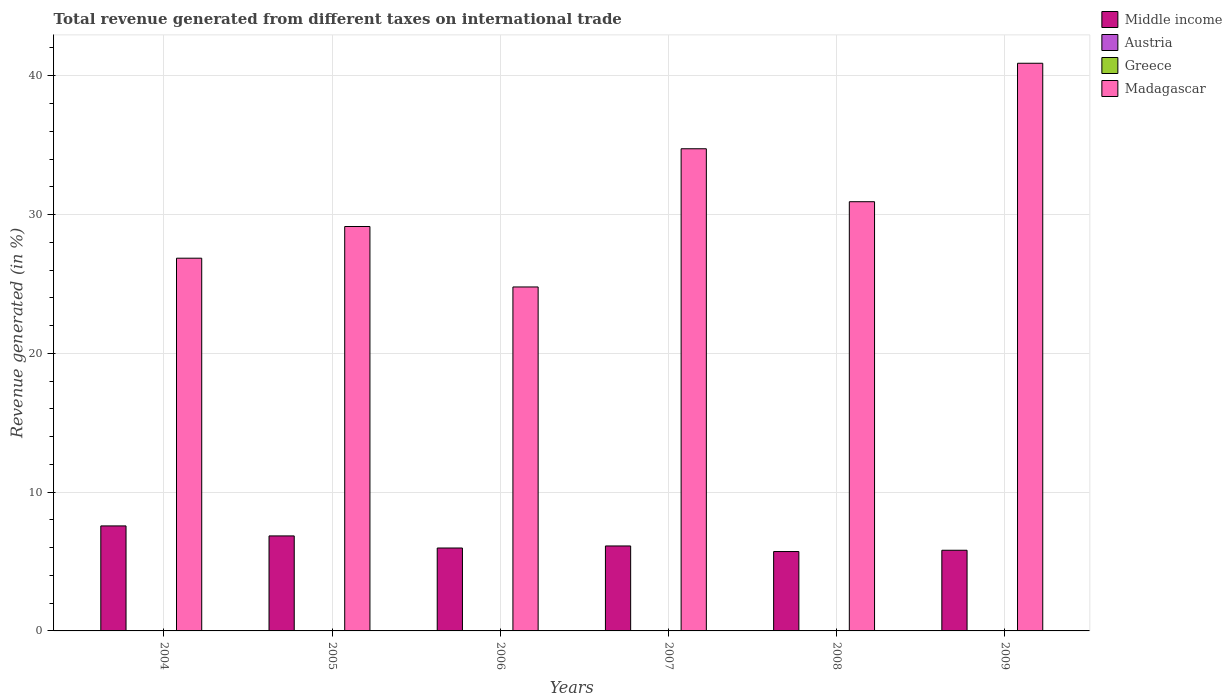How many different coloured bars are there?
Ensure brevity in your answer.  4. Are the number of bars per tick equal to the number of legend labels?
Keep it short and to the point. No. How many bars are there on the 3rd tick from the left?
Your answer should be compact. 4. In how many cases, is the number of bars for a given year not equal to the number of legend labels?
Keep it short and to the point. 2. What is the total revenue generated in Middle income in 2005?
Your response must be concise. 6.84. Across all years, what is the maximum total revenue generated in Middle income?
Keep it short and to the point. 7.57. Across all years, what is the minimum total revenue generated in Greece?
Offer a terse response. 0. What is the total total revenue generated in Middle income in the graph?
Give a very brief answer. 38.04. What is the difference between the total revenue generated in Greece in 2005 and that in 2008?
Your answer should be compact. 0. What is the difference between the total revenue generated in Greece in 2007 and the total revenue generated in Middle income in 2006?
Provide a short and direct response. -5.97. What is the average total revenue generated in Madagascar per year?
Offer a terse response. 31.22. In the year 2007, what is the difference between the total revenue generated in Greece and total revenue generated in Middle income?
Your answer should be very brief. -6.11. In how many years, is the total revenue generated in Madagascar greater than 16 %?
Provide a short and direct response. 6. What is the ratio of the total revenue generated in Greece in 2007 to that in 2008?
Offer a terse response. 3.65. Is the total revenue generated in Greece in 2004 less than that in 2005?
Offer a terse response. No. Is the difference between the total revenue generated in Greece in 2005 and 2009 greater than the difference between the total revenue generated in Middle income in 2005 and 2009?
Make the answer very short. No. What is the difference between the highest and the second highest total revenue generated in Greece?
Make the answer very short. 0.01. What is the difference between the highest and the lowest total revenue generated in Madagascar?
Keep it short and to the point. 16.12. In how many years, is the total revenue generated in Austria greater than the average total revenue generated in Austria taken over all years?
Keep it short and to the point. 2. Is it the case that in every year, the sum of the total revenue generated in Madagascar and total revenue generated in Austria is greater than the sum of total revenue generated in Middle income and total revenue generated in Greece?
Offer a terse response. Yes. Are all the bars in the graph horizontal?
Your response must be concise. No. What is the difference between two consecutive major ticks on the Y-axis?
Your response must be concise. 10. Does the graph contain any zero values?
Make the answer very short. Yes. Does the graph contain grids?
Offer a terse response. Yes. How many legend labels are there?
Make the answer very short. 4. How are the legend labels stacked?
Ensure brevity in your answer.  Vertical. What is the title of the graph?
Give a very brief answer. Total revenue generated from different taxes on international trade. What is the label or title of the X-axis?
Keep it short and to the point. Years. What is the label or title of the Y-axis?
Make the answer very short. Revenue generated (in %). What is the Revenue generated (in %) in Middle income in 2004?
Your answer should be compact. 7.57. What is the Revenue generated (in %) in Austria in 2004?
Provide a short and direct response. 0. What is the Revenue generated (in %) in Greece in 2004?
Provide a short and direct response. 0.01. What is the Revenue generated (in %) in Madagascar in 2004?
Make the answer very short. 26.85. What is the Revenue generated (in %) in Middle income in 2005?
Make the answer very short. 6.84. What is the Revenue generated (in %) of Austria in 2005?
Offer a terse response. 0. What is the Revenue generated (in %) in Greece in 2005?
Make the answer very short. 0. What is the Revenue generated (in %) in Madagascar in 2005?
Keep it short and to the point. 29.14. What is the Revenue generated (in %) of Middle income in 2006?
Keep it short and to the point. 5.97. What is the Revenue generated (in %) in Austria in 2006?
Provide a short and direct response. 7.23475776067297e-5. What is the Revenue generated (in %) in Greece in 2006?
Your answer should be very brief. 0.01. What is the Revenue generated (in %) in Madagascar in 2006?
Ensure brevity in your answer.  24.78. What is the Revenue generated (in %) in Middle income in 2007?
Your answer should be very brief. 6.12. What is the Revenue generated (in %) of Austria in 2007?
Offer a terse response. 0. What is the Revenue generated (in %) in Greece in 2007?
Keep it short and to the point. 0.01. What is the Revenue generated (in %) of Madagascar in 2007?
Provide a short and direct response. 34.74. What is the Revenue generated (in %) in Middle income in 2008?
Your response must be concise. 5.72. What is the Revenue generated (in %) in Greece in 2008?
Offer a very short reply. 0. What is the Revenue generated (in %) of Madagascar in 2008?
Offer a terse response. 30.92. What is the Revenue generated (in %) of Middle income in 2009?
Your response must be concise. 5.81. What is the Revenue generated (in %) of Austria in 2009?
Offer a very short reply. 6.92844166875675e-5. What is the Revenue generated (in %) in Greece in 2009?
Your answer should be very brief. 0. What is the Revenue generated (in %) in Madagascar in 2009?
Offer a terse response. 40.9. Across all years, what is the maximum Revenue generated (in %) in Middle income?
Offer a very short reply. 7.57. Across all years, what is the maximum Revenue generated (in %) of Austria?
Your answer should be compact. 0. Across all years, what is the maximum Revenue generated (in %) in Greece?
Ensure brevity in your answer.  0.01. Across all years, what is the maximum Revenue generated (in %) in Madagascar?
Make the answer very short. 40.9. Across all years, what is the minimum Revenue generated (in %) of Middle income?
Offer a terse response. 5.72. Across all years, what is the minimum Revenue generated (in %) in Greece?
Offer a very short reply. 0. Across all years, what is the minimum Revenue generated (in %) in Madagascar?
Provide a short and direct response. 24.78. What is the total Revenue generated (in %) in Middle income in the graph?
Ensure brevity in your answer.  38.04. What is the total Revenue generated (in %) in Austria in the graph?
Your response must be concise. 0.01. What is the total Revenue generated (in %) in Greece in the graph?
Give a very brief answer. 0.03. What is the total Revenue generated (in %) of Madagascar in the graph?
Offer a very short reply. 187.34. What is the difference between the Revenue generated (in %) in Middle income in 2004 and that in 2005?
Give a very brief answer. 0.72. What is the difference between the Revenue generated (in %) of Austria in 2004 and that in 2005?
Provide a succinct answer. 0. What is the difference between the Revenue generated (in %) of Greece in 2004 and that in 2005?
Your response must be concise. 0.01. What is the difference between the Revenue generated (in %) of Madagascar in 2004 and that in 2005?
Offer a very short reply. -2.28. What is the difference between the Revenue generated (in %) in Middle income in 2004 and that in 2006?
Keep it short and to the point. 1.59. What is the difference between the Revenue generated (in %) of Austria in 2004 and that in 2006?
Your answer should be compact. 0. What is the difference between the Revenue generated (in %) of Greece in 2004 and that in 2006?
Ensure brevity in your answer.  0.01. What is the difference between the Revenue generated (in %) of Madagascar in 2004 and that in 2006?
Give a very brief answer. 2.07. What is the difference between the Revenue generated (in %) of Middle income in 2004 and that in 2007?
Keep it short and to the point. 1.44. What is the difference between the Revenue generated (in %) of Greece in 2004 and that in 2007?
Give a very brief answer. 0.01. What is the difference between the Revenue generated (in %) in Madagascar in 2004 and that in 2007?
Offer a terse response. -7.88. What is the difference between the Revenue generated (in %) in Middle income in 2004 and that in 2008?
Your answer should be very brief. 1.85. What is the difference between the Revenue generated (in %) in Greece in 2004 and that in 2008?
Your answer should be compact. 0.01. What is the difference between the Revenue generated (in %) of Madagascar in 2004 and that in 2008?
Provide a short and direct response. -4.07. What is the difference between the Revenue generated (in %) in Middle income in 2004 and that in 2009?
Your answer should be very brief. 1.75. What is the difference between the Revenue generated (in %) of Austria in 2004 and that in 2009?
Make the answer very short. 0. What is the difference between the Revenue generated (in %) of Greece in 2004 and that in 2009?
Your answer should be very brief. 0.01. What is the difference between the Revenue generated (in %) of Madagascar in 2004 and that in 2009?
Your response must be concise. -14.05. What is the difference between the Revenue generated (in %) in Middle income in 2005 and that in 2006?
Keep it short and to the point. 0.87. What is the difference between the Revenue generated (in %) of Austria in 2005 and that in 2006?
Offer a terse response. 0. What is the difference between the Revenue generated (in %) of Greece in 2005 and that in 2006?
Your answer should be very brief. -0. What is the difference between the Revenue generated (in %) in Madagascar in 2005 and that in 2006?
Offer a terse response. 4.36. What is the difference between the Revenue generated (in %) of Middle income in 2005 and that in 2007?
Give a very brief answer. 0.72. What is the difference between the Revenue generated (in %) in Greece in 2005 and that in 2007?
Your answer should be very brief. -0. What is the difference between the Revenue generated (in %) in Madagascar in 2005 and that in 2007?
Provide a succinct answer. -5.6. What is the difference between the Revenue generated (in %) in Middle income in 2005 and that in 2008?
Provide a succinct answer. 1.13. What is the difference between the Revenue generated (in %) of Greece in 2005 and that in 2008?
Your response must be concise. 0. What is the difference between the Revenue generated (in %) in Madagascar in 2005 and that in 2008?
Make the answer very short. -1.79. What is the difference between the Revenue generated (in %) of Middle income in 2005 and that in 2009?
Offer a terse response. 1.03. What is the difference between the Revenue generated (in %) of Austria in 2005 and that in 2009?
Offer a terse response. 0. What is the difference between the Revenue generated (in %) of Greece in 2005 and that in 2009?
Provide a short and direct response. 0. What is the difference between the Revenue generated (in %) in Madagascar in 2005 and that in 2009?
Your answer should be very brief. -11.76. What is the difference between the Revenue generated (in %) in Middle income in 2006 and that in 2007?
Your response must be concise. -0.15. What is the difference between the Revenue generated (in %) of Greece in 2006 and that in 2007?
Provide a succinct answer. -0. What is the difference between the Revenue generated (in %) in Madagascar in 2006 and that in 2007?
Give a very brief answer. -9.96. What is the difference between the Revenue generated (in %) of Middle income in 2006 and that in 2008?
Keep it short and to the point. 0.25. What is the difference between the Revenue generated (in %) in Greece in 2006 and that in 2008?
Give a very brief answer. 0. What is the difference between the Revenue generated (in %) in Madagascar in 2006 and that in 2008?
Your answer should be very brief. -6.14. What is the difference between the Revenue generated (in %) in Middle income in 2006 and that in 2009?
Keep it short and to the point. 0.16. What is the difference between the Revenue generated (in %) in Austria in 2006 and that in 2009?
Keep it short and to the point. 0. What is the difference between the Revenue generated (in %) of Greece in 2006 and that in 2009?
Provide a short and direct response. 0. What is the difference between the Revenue generated (in %) of Madagascar in 2006 and that in 2009?
Make the answer very short. -16.12. What is the difference between the Revenue generated (in %) of Middle income in 2007 and that in 2008?
Make the answer very short. 0.4. What is the difference between the Revenue generated (in %) of Greece in 2007 and that in 2008?
Provide a succinct answer. 0.01. What is the difference between the Revenue generated (in %) in Madagascar in 2007 and that in 2008?
Offer a very short reply. 3.82. What is the difference between the Revenue generated (in %) in Middle income in 2007 and that in 2009?
Keep it short and to the point. 0.31. What is the difference between the Revenue generated (in %) of Greece in 2007 and that in 2009?
Keep it short and to the point. 0.01. What is the difference between the Revenue generated (in %) of Madagascar in 2007 and that in 2009?
Give a very brief answer. -6.16. What is the difference between the Revenue generated (in %) of Middle income in 2008 and that in 2009?
Offer a terse response. -0.09. What is the difference between the Revenue generated (in %) of Greece in 2008 and that in 2009?
Provide a succinct answer. 0. What is the difference between the Revenue generated (in %) of Madagascar in 2008 and that in 2009?
Provide a short and direct response. -9.98. What is the difference between the Revenue generated (in %) in Middle income in 2004 and the Revenue generated (in %) in Austria in 2005?
Make the answer very short. 7.56. What is the difference between the Revenue generated (in %) of Middle income in 2004 and the Revenue generated (in %) of Greece in 2005?
Provide a short and direct response. 7.56. What is the difference between the Revenue generated (in %) in Middle income in 2004 and the Revenue generated (in %) in Madagascar in 2005?
Provide a succinct answer. -21.57. What is the difference between the Revenue generated (in %) of Austria in 2004 and the Revenue generated (in %) of Madagascar in 2005?
Your response must be concise. -29.13. What is the difference between the Revenue generated (in %) of Greece in 2004 and the Revenue generated (in %) of Madagascar in 2005?
Provide a succinct answer. -29.12. What is the difference between the Revenue generated (in %) in Middle income in 2004 and the Revenue generated (in %) in Austria in 2006?
Ensure brevity in your answer.  7.57. What is the difference between the Revenue generated (in %) of Middle income in 2004 and the Revenue generated (in %) of Greece in 2006?
Offer a terse response. 7.56. What is the difference between the Revenue generated (in %) of Middle income in 2004 and the Revenue generated (in %) of Madagascar in 2006?
Give a very brief answer. -17.22. What is the difference between the Revenue generated (in %) in Austria in 2004 and the Revenue generated (in %) in Greece in 2006?
Give a very brief answer. -0. What is the difference between the Revenue generated (in %) of Austria in 2004 and the Revenue generated (in %) of Madagascar in 2006?
Provide a short and direct response. -24.78. What is the difference between the Revenue generated (in %) in Greece in 2004 and the Revenue generated (in %) in Madagascar in 2006?
Provide a succinct answer. -24.77. What is the difference between the Revenue generated (in %) in Middle income in 2004 and the Revenue generated (in %) in Greece in 2007?
Make the answer very short. 7.56. What is the difference between the Revenue generated (in %) of Middle income in 2004 and the Revenue generated (in %) of Madagascar in 2007?
Your answer should be compact. -27.17. What is the difference between the Revenue generated (in %) in Austria in 2004 and the Revenue generated (in %) in Greece in 2007?
Offer a terse response. -0. What is the difference between the Revenue generated (in %) in Austria in 2004 and the Revenue generated (in %) in Madagascar in 2007?
Offer a very short reply. -34.73. What is the difference between the Revenue generated (in %) in Greece in 2004 and the Revenue generated (in %) in Madagascar in 2007?
Your answer should be compact. -34.72. What is the difference between the Revenue generated (in %) of Middle income in 2004 and the Revenue generated (in %) of Greece in 2008?
Provide a short and direct response. 7.56. What is the difference between the Revenue generated (in %) in Middle income in 2004 and the Revenue generated (in %) in Madagascar in 2008?
Your response must be concise. -23.36. What is the difference between the Revenue generated (in %) in Austria in 2004 and the Revenue generated (in %) in Greece in 2008?
Offer a very short reply. 0. What is the difference between the Revenue generated (in %) of Austria in 2004 and the Revenue generated (in %) of Madagascar in 2008?
Provide a succinct answer. -30.92. What is the difference between the Revenue generated (in %) of Greece in 2004 and the Revenue generated (in %) of Madagascar in 2008?
Provide a succinct answer. -30.91. What is the difference between the Revenue generated (in %) in Middle income in 2004 and the Revenue generated (in %) in Austria in 2009?
Offer a very short reply. 7.57. What is the difference between the Revenue generated (in %) of Middle income in 2004 and the Revenue generated (in %) of Greece in 2009?
Provide a short and direct response. 7.56. What is the difference between the Revenue generated (in %) of Middle income in 2004 and the Revenue generated (in %) of Madagascar in 2009?
Your answer should be compact. -33.33. What is the difference between the Revenue generated (in %) of Austria in 2004 and the Revenue generated (in %) of Greece in 2009?
Provide a succinct answer. 0. What is the difference between the Revenue generated (in %) of Austria in 2004 and the Revenue generated (in %) of Madagascar in 2009?
Offer a very short reply. -40.9. What is the difference between the Revenue generated (in %) of Greece in 2004 and the Revenue generated (in %) of Madagascar in 2009?
Offer a very short reply. -40.88. What is the difference between the Revenue generated (in %) of Middle income in 2005 and the Revenue generated (in %) of Austria in 2006?
Make the answer very short. 6.84. What is the difference between the Revenue generated (in %) in Middle income in 2005 and the Revenue generated (in %) in Greece in 2006?
Make the answer very short. 6.84. What is the difference between the Revenue generated (in %) of Middle income in 2005 and the Revenue generated (in %) of Madagascar in 2006?
Ensure brevity in your answer.  -17.94. What is the difference between the Revenue generated (in %) in Austria in 2005 and the Revenue generated (in %) in Greece in 2006?
Keep it short and to the point. -0. What is the difference between the Revenue generated (in %) of Austria in 2005 and the Revenue generated (in %) of Madagascar in 2006?
Provide a succinct answer. -24.78. What is the difference between the Revenue generated (in %) of Greece in 2005 and the Revenue generated (in %) of Madagascar in 2006?
Ensure brevity in your answer.  -24.78. What is the difference between the Revenue generated (in %) in Middle income in 2005 and the Revenue generated (in %) in Greece in 2007?
Your response must be concise. 6.84. What is the difference between the Revenue generated (in %) in Middle income in 2005 and the Revenue generated (in %) in Madagascar in 2007?
Your answer should be very brief. -27.89. What is the difference between the Revenue generated (in %) of Austria in 2005 and the Revenue generated (in %) of Greece in 2007?
Your answer should be very brief. -0.01. What is the difference between the Revenue generated (in %) in Austria in 2005 and the Revenue generated (in %) in Madagascar in 2007?
Your answer should be compact. -34.74. What is the difference between the Revenue generated (in %) of Greece in 2005 and the Revenue generated (in %) of Madagascar in 2007?
Offer a very short reply. -34.73. What is the difference between the Revenue generated (in %) in Middle income in 2005 and the Revenue generated (in %) in Greece in 2008?
Keep it short and to the point. 6.84. What is the difference between the Revenue generated (in %) of Middle income in 2005 and the Revenue generated (in %) of Madagascar in 2008?
Provide a succinct answer. -24.08. What is the difference between the Revenue generated (in %) in Austria in 2005 and the Revenue generated (in %) in Greece in 2008?
Give a very brief answer. -0. What is the difference between the Revenue generated (in %) of Austria in 2005 and the Revenue generated (in %) of Madagascar in 2008?
Your answer should be compact. -30.92. What is the difference between the Revenue generated (in %) of Greece in 2005 and the Revenue generated (in %) of Madagascar in 2008?
Offer a very short reply. -30.92. What is the difference between the Revenue generated (in %) in Middle income in 2005 and the Revenue generated (in %) in Austria in 2009?
Your answer should be very brief. 6.84. What is the difference between the Revenue generated (in %) of Middle income in 2005 and the Revenue generated (in %) of Greece in 2009?
Provide a succinct answer. 6.84. What is the difference between the Revenue generated (in %) of Middle income in 2005 and the Revenue generated (in %) of Madagascar in 2009?
Provide a succinct answer. -34.05. What is the difference between the Revenue generated (in %) of Austria in 2005 and the Revenue generated (in %) of Greece in 2009?
Provide a succinct answer. 0. What is the difference between the Revenue generated (in %) of Austria in 2005 and the Revenue generated (in %) of Madagascar in 2009?
Your answer should be compact. -40.9. What is the difference between the Revenue generated (in %) of Greece in 2005 and the Revenue generated (in %) of Madagascar in 2009?
Your response must be concise. -40.9. What is the difference between the Revenue generated (in %) of Middle income in 2006 and the Revenue generated (in %) of Greece in 2007?
Provide a short and direct response. 5.97. What is the difference between the Revenue generated (in %) in Middle income in 2006 and the Revenue generated (in %) in Madagascar in 2007?
Provide a succinct answer. -28.77. What is the difference between the Revenue generated (in %) of Austria in 2006 and the Revenue generated (in %) of Greece in 2007?
Ensure brevity in your answer.  -0.01. What is the difference between the Revenue generated (in %) of Austria in 2006 and the Revenue generated (in %) of Madagascar in 2007?
Your answer should be very brief. -34.74. What is the difference between the Revenue generated (in %) in Greece in 2006 and the Revenue generated (in %) in Madagascar in 2007?
Your answer should be very brief. -34.73. What is the difference between the Revenue generated (in %) in Middle income in 2006 and the Revenue generated (in %) in Greece in 2008?
Keep it short and to the point. 5.97. What is the difference between the Revenue generated (in %) of Middle income in 2006 and the Revenue generated (in %) of Madagascar in 2008?
Give a very brief answer. -24.95. What is the difference between the Revenue generated (in %) in Austria in 2006 and the Revenue generated (in %) in Greece in 2008?
Make the answer very short. -0. What is the difference between the Revenue generated (in %) of Austria in 2006 and the Revenue generated (in %) of Madagascar in 2008?
Keep it short and to the point. -30.92. What is the difference between the Revenue generated (in %) in Greece in 2006 and the Revenue generated (in %) in Madagascar in 2008?
Provide a short and direct response. -30.92. What is the difference between the Revenue generated (in %) in Middle income in 2006 and the Revenue generated (in %) in Austria in 2009?
Provide a succinct answer. 5.97. What is the difference between the Revenue generated (in %) of Middle income in 2006 and the Revenue generated (in %) of Greece in 2009?
Offer a very short reply. 5.97. What is the difference between the Revenue generated (in %) of Middle income in 2006 and the Revenue generated (in %) of Madagascar in 2009?
Ensure brevity in your answer.  -34.93. What is the difference between the Revenue generated (in %) of Austria in 2006 and the Revenue generated (in %) of Greece in 2009?
Make the answer very short. -0. What is the difference between the Revenue generated (in %) in Austria in 2006 and the Revenue generated (in %) in Madagascar in 2009?
Provide a succinct answer. -40.9. What is the difference between the Revenue generated (in %) of Greece in 2006 and the Revenue generated (in %) of Madagascar in 2009?
Your answer should be very brief. -40.89. What is the difference between the Revenue generated (in %) of Middle income in 2007 and the Revenue generated (in %) of Greece in 2008?
Give a very brief answer. 6.12. What is the difference between the Revenue generated (in %) in Middle income in 2007 and the Revenue generated (in %) in Madagascar in 2008?
Offer a terse response. -24.8. What is the difference between the Revenue generated (in %) in Greece in 2007 and the Revenue generated (in %) in Madagascar in 2008?
Your response must be concise. -30.92. What is the difference between the Revenue generated (in %) in Middle income in 2007 and the Revenue generated (in %) in Austria in 2009?
Provide a succinct answer. 6.12. What is the difference between the Revenue generated (in %) in Middle income in 2007 and the Revenue generated (in %) in Greece in 2009?
Your answer should be very brief. 6.12. What is the difference between the Revenue generated (in %) in Middle income in 2007 and the Revenue generated (in %) in Madagascar in 2009?
Provide a succinct answer. -34.78. What is the difference between the Revenue generated (in %) in Greece in 2007 and the Revenue generated (in %) in Madagascar in 2009?
Make the answer very short. -40.89. What is the difference between the Revenue generated (in %) in Middle income in 2008 and the Revenue generated (in %) in Austria in 2009?
Offer a very short reply. 5.72. What is the difference between the Revenue generated (in %) in Middle income in 2008 and the Revenue generated (in %) in Greece in 2009?
Provide a succinct answer. 5.72. What is the difference between the Revenue generated (in %) in Middle income in 2008 and the Revenue generated (in %) in Madagascar in 2009?
Your answer should be compact. -35.18. What is the difference between the Revenue generated (in %) of Greece in 2008 and the Revenue generated (in %) of Madagascar in 2009?
Offer a very short reply. -40.9. What is the average Revenue generated (in %) in Middle income per year?
Make the answer very short. 6.34. What is the average Revenue generated (in %) in Austria per year?
Your answer should be compact. 0. What is the average Revenue generated (in %) in Greece per year?
Your answer should be very brief. 0.01. What is the average Revenue generated (in %) of Madagascar per year?
Provide a short and direct response. 31.22. In the year 2004, what is the difference between the Revenue generated (in %) of Middle income and Revenue generated (in %) of Austria?
Offer a terse response. 7.56. In the year 2004, what is the difference between the Revenue generated (in %) of Middle income and Revenue generated (in %) of Greece?
Provide a succinct answer. 7.55. In the year 2004, what is the difference between the Revenue generated (in %) in Middle income and Revenue generated (in %) in Madagascar?
Keep it short and to the point. -19.29. In the year 2004, what is the difference between the Revenue generated (in %) of Austria and Revenue generated (in %) of Greece?
Make the answer very short. -0.01. In the year 2004, what is the difference between the Revenue generated (in %) in Austria and Revenue generated (in %) in Madagascar?
Provide a succinct answer. -26.85. In the year 2004, what is the difference between the Revenue generated (in %) in Greece and Revenue generated (in %) in Madagascar?
Keep it short and to the point. -26.84. In the year 2005, what is the difference between the Revenue generated (in %) in Middle income and Revenue generated (in %) in Austria?
Make the answer very short. 6.84. In the year 2005, what is the difference between the Revenue generated (in %) in Middle income and Revenue generated (in %) in Greece?
Ensure brevity in your answer.  6.84. In the year 2005, what is the difference between the Revenue generated (in %) of Middle income and Revenue generated (in %) of Madagascar?
Give a very brief answer. -22.29. In the year 2005, what is the difference between the Revenue generated (in %) in Austria and Revenue generated (in %) in Greece?
Give a very brief answer. -0. In the year 2005, what is the difference between the Revenue generated (in %) in Austria and Revenue generated (in %) in Madagascar?
Give a very brief answer. -29.14. In the year 2005, what is the difference between the Revenue generated (in %) in Greece and Revenue generated (in %) in Madagascar?
Ensure brevity in your answer.  -29.13. In the year 2006, what is the difference between the Revenue generated (in %) in Middle income and Revenue generated (in %) in Austria?
Keep it short and to the point. 5.97. In the year 2006, what is the difference between the Revenue generated (in %) of Middle income and Revenue generated (in %) of Greece?
Provide a short and direct response. 5.97. In the year 2006, what is the difference between the Revenue generated (in %) in Middle income and Revenue generated (in %) in Madagascar?
Keep it short and to the point. -18.81. In the year 2006, what is the difference between the Revenue generated (in %) in Austria and Revenue generated (in %) in Greece?
Provide a succinct answer. -0. In the year 2006, what is the difference between the Revenue generated (in %) in Austria and Revenue generated (in %) in Madagascar?
Ensure brevity in your answer.  -24.78. In the year 2006, what is the difference between the Revenue generated (in %) in Greece and Revenue generated (in %) in Madagascar?
Ensure brevity in your answer.  -24.78. In the year 2007, what is the difference between the Revenue generated (in %) of Middle income and Revenue generated (in %) of Greece?
Provide a short and direct response. 6.11. In the year 2007, what is the difference between the Revenue generated (in %) of Middle income and Revenue generated (in %) of Madagascar?
Offer a very short reply. -28.62. In the year 2007, what is the difference between the Revenue generated (in %) in Greece and Revenue generated (in %) in Madagascar?
Your answer should be compact. -34.73. In the year 2008, what is the difference between the Revenue generated (in %) in Middle income and Revenue generated (in %) in Greece?
Offer a very short reply. 5.72. In the year 2008, what is the difference between the Revenue generated (in %) of Middle income and Revenue generated (in %) of Madagascar?
Ensure brevity in your answer.  -25.2. In the year 2008, what is the difference between the Revenue generated (in %) in Greece and Revenue generated (in %) in Madagascar?
Offer a very short reply. -30.92. In the year 2009, what is the difference between the Revenue generated (in %) of Middle income and Revenue generated (in %) of Austria?
Offer a very short reply. 5.81. In the year 2009, what is the difference between the Revenue generated (in %) of Middle income and Revenue generated (in %) of Greece?
Offer a terse response. 5.81. In the year 2009, what is the difference between the Revenue generated (in %) in Middle income and Revenue generated (in %) in Madagascar?
Make the answer very short. -35.09. In the year 2009, what is the difference between the Revenue generated (in %) in Austria and Revenue generated (in %) in Greece?
Your answer should be compact. -0. In the year 2009, what is the difference between the Revenue generated (in %) in Austria and Revenue generated (in %) in Madagascar?
Your answer should be very brief. -40.9. In the year 2009, what is the difference between the Revenue generated (in %) of Greece and Revenue generated (in %) of Madagascar?
Provide a short and direct response. -40.9. What is the ratio of the Revenue generated (in %) of Middle income in 2004 to that in 2005?
Provide a succinct answer. 1.11. What is the ratio of the Revenue generated (in %) in Austria in 2004 to that in 2005?
Give a very brief answer. 2.81. What is the ratio of the Revenue generated (in %) of Greece in 2004 to that in 2005?
Ensure brevity in your answer.  3.55. What is the ratio of the Revenue generated (in %) in Madagascar in 2004 to that in 2005?
Your answer should be very brief. 0.92. What is the ratio of the Revenue generated (in %) in Middle income in 2004 to that in 2006?
Provide a succinct answer. 1.27. What is the ratio of the Revenue generated (in %) of Austria in 2004 to that in 2006?
Provide a succinct answer. 59.87. What is the ratio of the Revenue generated (in %) of Greece in 2004 to that in 2006?
Ensure brevity in your answer.  2.9. What is the ratio of the Revenue generated (in %) in Madagascar in 2004 to that in 2006?
Your answer should be very brief. 1.08. What is the ratio of the Revenue generated (in %) in Middle income in 2004 to that in 2007?
Offer a terse response. 1.24. What is the ratio of the Revenue generated (in %) of Greece in 2004 to that in 2007?
Your response must be concise. 1.84. What is the ratio of the Revenue generated (in %) of Madagascar in 2004 to that in 2007?
Your answer should be compact. 0.77. What is the ratio of the Revenue generated (in %) in Middle income in 2004 to that in 2008?
Give a very brief answer. 1.32. What is the ratio of the Revenue generated (in %) in Greece in 2004 to that in 2008?
Provide a succinct answer. 6.71. What is the ratio of the Revenue generated (in %) in Madagascar in 2004 to that in 2008?
Offer a terse response. 0.87. What is the ratio of the Revenue generated (in %) in Middle income in 2004 to that in 2009?
Offer a terse response. 1.3. What is the ratio of the Revenue generated (in %) in Austria in 2004 to that in 2009?
Your answer should be compact. 62.52. What is the ratio of the Revenue generated (in %) in Greece in 2004 to that in 2009?
Provide a short and direct response. 12.5. What is the ratio of the Revenue generated (in %) of Madagascar in 2004 to that in 2009?
Offer a terse response. 0.66. What is the ratio of the Revenue generated (in %) of Middle income in 2005 to that in 2006?
Provide a short and direct response. 1.15. What is the ratio of the Revenue generated (in %) in Austria in 2005 to that in 2006?
Provide a short and direct response. 21.3. What is the ratio of the Revenue generated (in %) in Greece in 2005 to that in 2006?
Offer a very short reply. 0.82. What is the ratio of the Revenue generated (in %) in Madagascar in 2005 to that in 2006?
Offer a very short reply. 1.18. What is the ratio of the Revenue generated (in %) in Middle income in 2005 to that in 2007?
Offer a very short reply. 1.12. What is the ratio of the Revenue generated (in %) of Greece in 2005 to that in 2007?
Your answer should be compact. 0.52. What is the ratio of the Revenue generated (in %) in Madagascar in 2005 to that in 2007?
Your answer should be compact. 0.84. What is the ratio of the Revenue generated (in %) of Middle income in 2005 to that in 2008?
Keep it short and to the point. 1.2. What is the ratio of the Revenue generated (in %) of Greece in 2005 to that in 2008?
Give a very brief answer. 1.89. What is the ratio of the Revenue generated (in %) in Madagascar in 2005 to that in 2008?
Ensure brevity in your answer.  0.94. What is the ratio of the Revenue generated (in %) in Middle income in 2005 to that in 2009?
Offer a terse response. 1.18. What is the ratio of the Revenue generated (in %) in Austria in 2005 to that in 2009?
Offer a terse response. 22.24. What is the ratio of the Revenue generated (in %) of Greece in 2005 to that in 2009?
Give a very brief answer. 3.52. What is the ratio of the Revenue generated (in %) of Madagascar in 2005 to that in 2009?
Provide a short and direct response. 0.71. What is the ratio of the Revenue generated (in %) of Middle income in 2006 to that in 2007?
Give a very brief answer. 0.98. What is the ratio of the Revenue generated (in %) of Greece in 2006 to that in 2007?
Your response must be concise. 0.63. What is the ratio of the Revenue generated (in %) of Madagascar in 2006 to that in 2007?
Your answer should be compact. 0.71. What is the ratio of the Revenue generated (in %) in Middle income in 2006 to that in 2008?
Your answer should be very brief. 1.04. What is the ratio of the Revenue generated (in %) of Greece in 2006 to that in 2008?
Offer a very short reply. 2.32. What is the ratio of the Revenue generated (in %) of Madagascar in 2006 to that in 2008?
Ensure brevity in your answer.  0.8. What is the ratio of the Revenue generated (in %) in Middle income in 2006 to that in 2009?
Offer a terse response. 1.03. What is the ratio of the Revenue generated (in %) in Austria in 2006 to that in 2009?
Offer a terse response. 1.04. What is the ratio of the Revenue generated (in %) of Greece in 2006 to that in 2009?
Provide a succinct answer. 4.31. What is the ratio of the Revenue generated (in %) of Madagascar in 2006 to that in 2009?
Give a very brief answer. 0.61. What is the ratio of the Revenue generated (in %) of Middle income in 2007 to that in 2008?
Offer a terse response. 1.07. What is the ratio of the Revenue generated (in %) in Greece in 2007 to that in 2008?
Provide a succinct answer. 3.65. What is the ratio of the Revenue generated (in %) of Madagascar in 2007 to that in 2008?
Your answer should be very brief. 1.12. What is the ratio of the Revenue generated (in %) of Middle income in 2007 to that in 2009?
Make the answer very short. 1.05. What is the ratio of the Revenue generated (in %) in Greece in 2007 to that in 2009?
Offer a terse response. 6.79. What is the ratio of the Revenue generated (in %) of Madagascar in 2007 to that in 2009?
Provide a short and direct response. 0.85. What is the ratio of the Revenue generated (in %) in Middle income in 2008 to that in 2009?
Offer a very short reply. 0.98. What is the ratio of the Revenue generated (in %) in Greece in 2008 to that in 2009?
Keep it short and to the point. 1.86. What is the ratio of the Revenue generated (in %) of Madagascar in 2008 to that in 2009?
Offer a terse response. 0.76. What is the difference between the highest and the second highest Revenue generated (in %) of Middle income?
Your response must be concise. 0.72. What is the difference between the highest and the second highest Revenue generated (in %) of Austria?
Give a very brief answer. 0. What is the difference between the highest and the second highest Revenue generated (in %) in Greece?
Keep it short and to the point. 0.01. What is the difference between the highest and the second highest Revenue generated (in %) of Madagascar?
Offer a very short reply. 6.16. What is the difference between the highest and the lowest Revenue generated (in %) of Middle income?
Keep it short and to the point. 1.85. What is the difference between the highest and the lowest Revenue generated (in %) of Austria?
Ensure brevity in your answer.  0. What is the difference between the highest and the lowest Revenue generated (in %) in Greece?
Offer a terse response. 0.01. What is the difference between the highest and the lowest Revenue generated (in %) of Madagascar?
Your answer should be very brief. 16.12. 